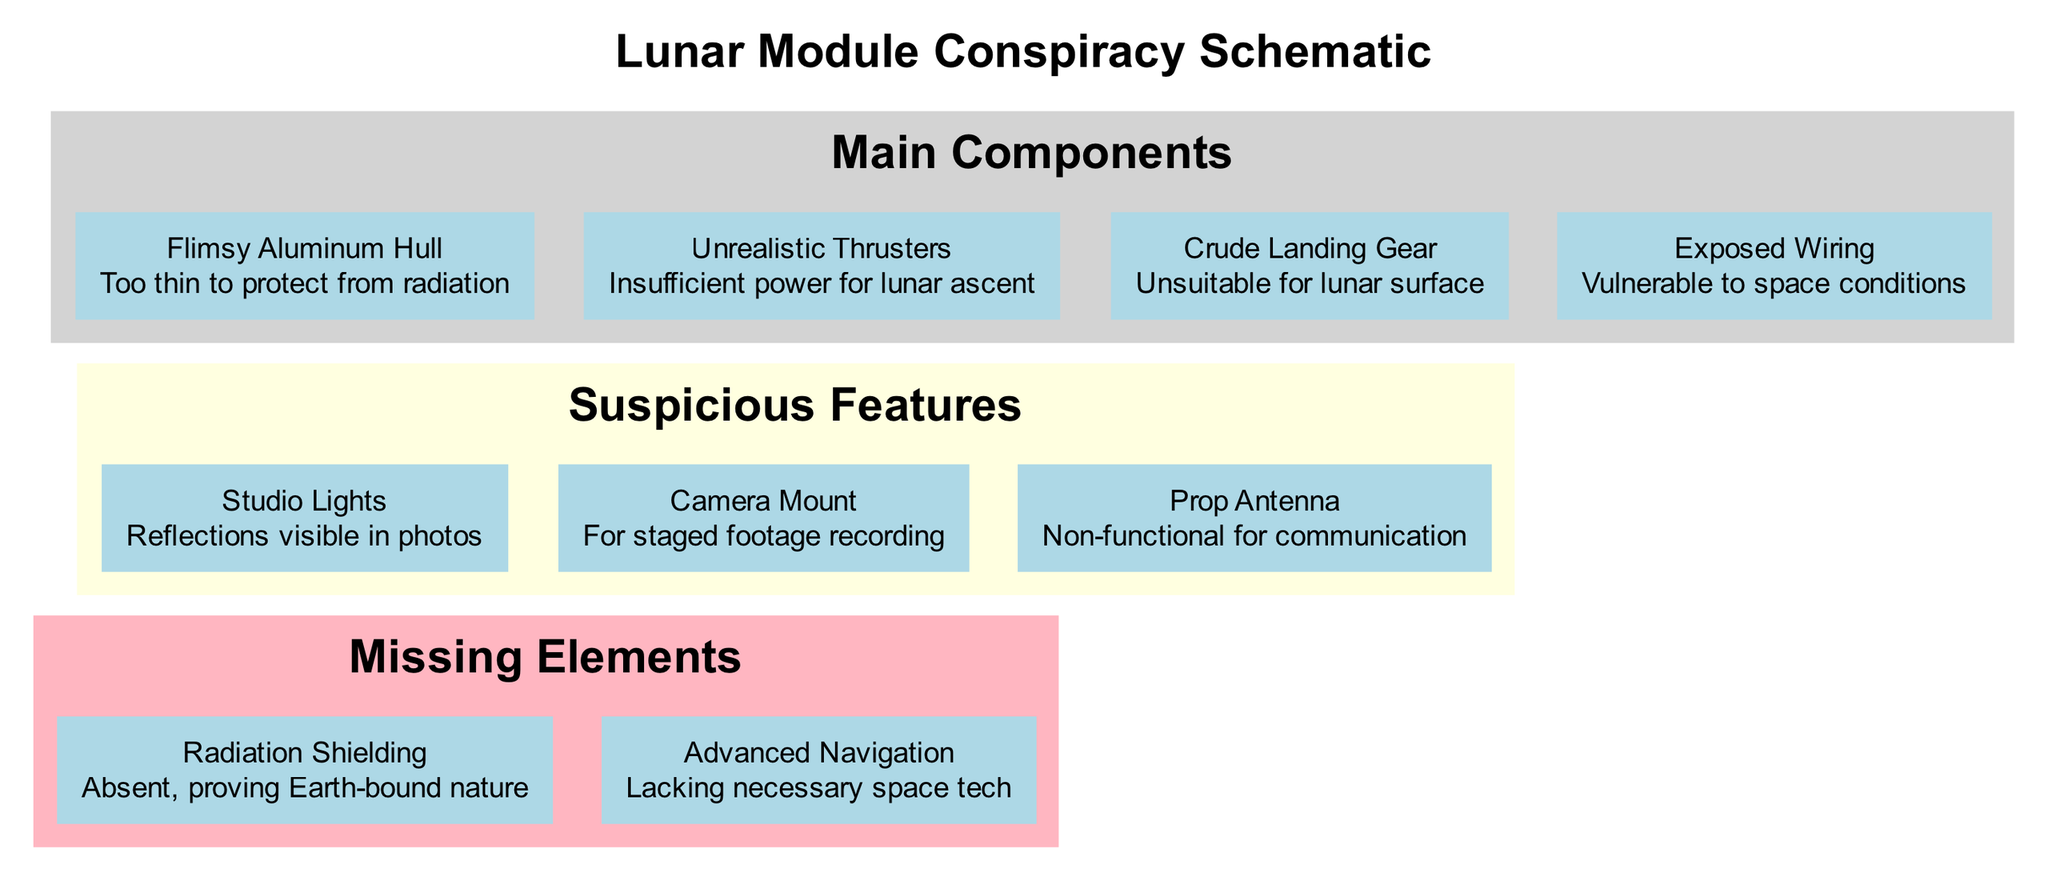What is the component made of thin material? The diagram identifies the "Flimsy Aluminum Hull" as a main component. This name indicates it is specifically made of thin material.
Answer: Flimsy Aluminum Hull How many suspicious features are listed? The diagram includes a total of three suspicious features: Studio Lights, Camera Mount, and Prop Antenna. Counting them gives us the answer.
Answer: 3 What is indicated as absent in the diagram? The diagram mentions "Radiation Shielding" as a missing element, specifically stated as absent and proving Earth-bound nature.
Answer: Radiation Shielding Which main component is described as having insufficient power? The "Unrealistic Thrusters" are highlighted in the diagram as having insufficient power for lunar ascent, according to the description provided.
Answer: Unrealistic Thrusters What is next to the "Exposed Wiring" in the layout? In the organization of the diagram, "Exposed Wiring" is in the main components section, but there is an invisible edge connecting it to "Studio Lights", indicating a relationship or proximity in the layout.
Answer: Studio Lights What feature is claimed to be for staged footage recording? The diagram points out "Camera Mount" as the feature intended for staged footage recording, which infers that it was used to capture fabricated images.
Answer: Camera Mount Are there any missing elements related to space technology? Yes, "Advanced Navigation" is listed as a missing element in the diagram, highlighting its lack of necessary space tech. This confirms that it pertains to space technology.
Answer: Advanced Navigation What color is the suspicious features subgraph? The suspicious features subgraph is colored light yellow according to the diagram's designations.
Answer: Light yellow What are the main components of the schematic? The main components include "Flimsy Aluminum Hull," "Unrealistic Thrusters," "Crude Landing Gear," and "Exposed Wiring." Listing them shows the entire classification.
Answer: Flimsy Aluminum Hull, Unrealistic Thrusters, Crude Landing Gear, Exposed Wiring 